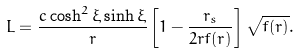<formula> <loc_0><loc_0><loc_500><loc_500>L = \frac { c \cosh ^ { 2 } \xi \sinh \xi } { r } \left [ 1 - \frac { r _ { s } } { 2 r f ( r ) } \right ] \sqrt { f ( r ) } .</formula> 